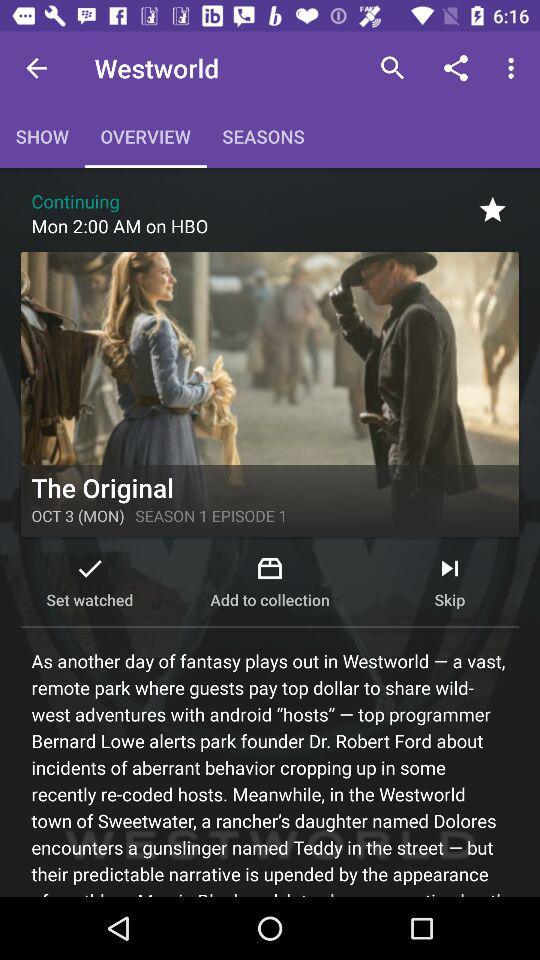What is the title of the show? The title of the show is "The Original". 